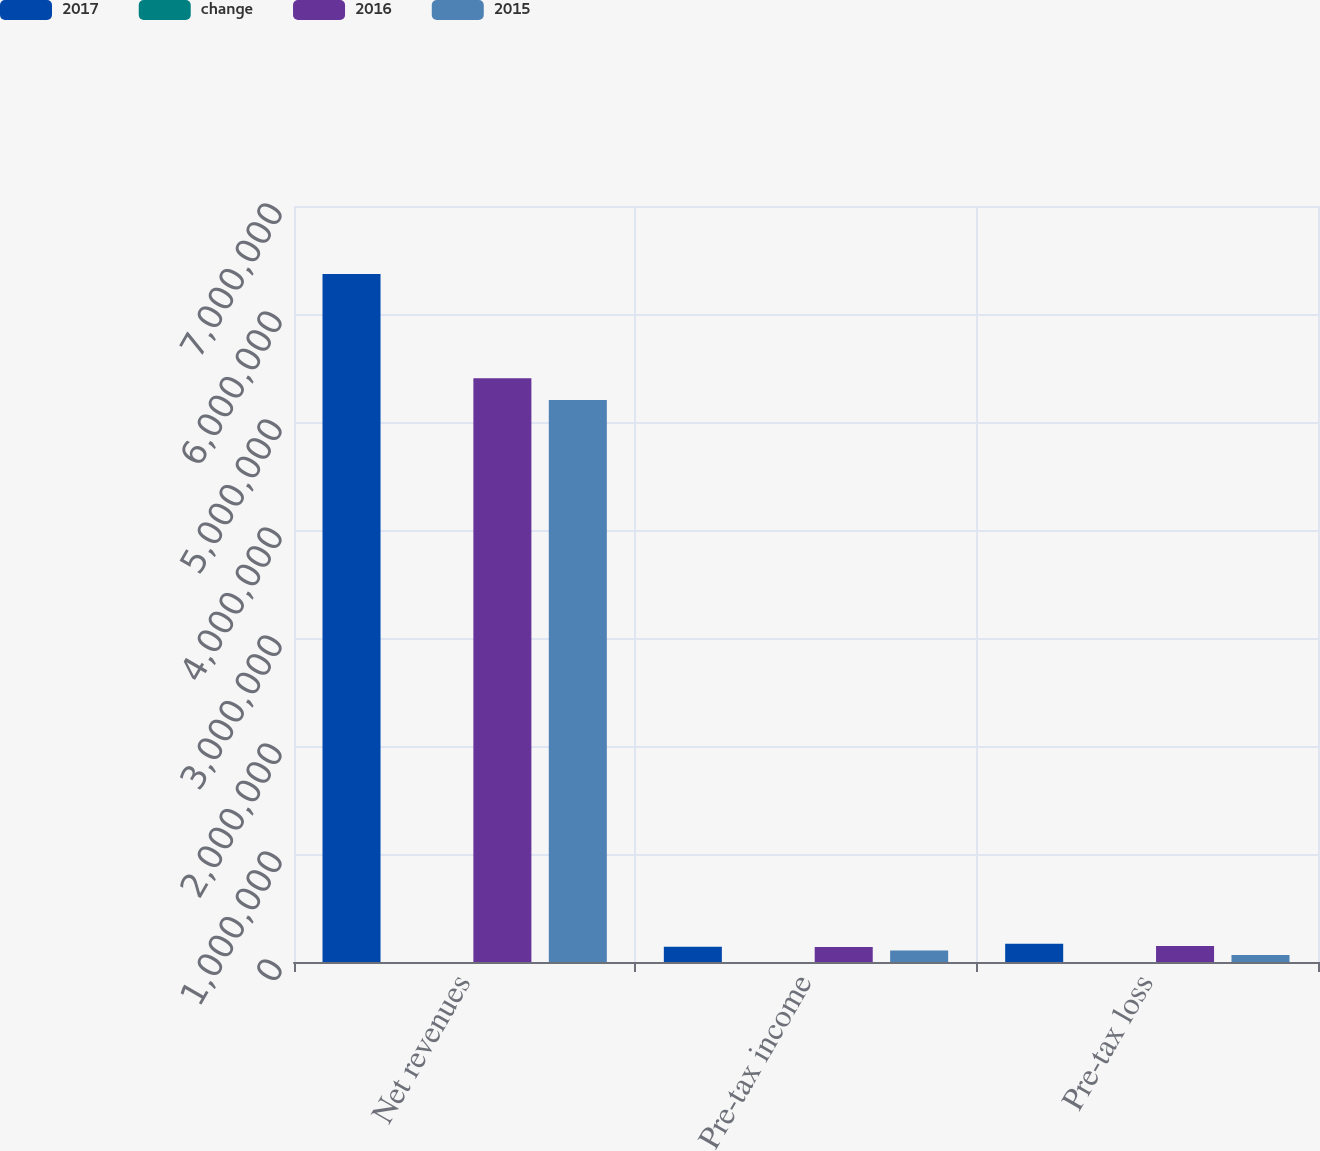Convert chart to OTSL. <chart><loc_0><loc_0><loc_500><loc_500><stacked_bar_chart><ecel><fcel>Net revenues<fcel>Pre-tax income<fcel>Pre-tax loss<nl><fcel>2017<fcel>6.3711e+06<fcel>141236<fcel>169879<nl><fcel>change<fcel>18<fcel>1<fcel>14<nl><fcel>2016<fcel>5.40506e+06<fcel>139173<fcel>148548<nl><fcel>2015<fcel>5.20361e+06<fcel>107009<fcel>64849<nl></chart> 